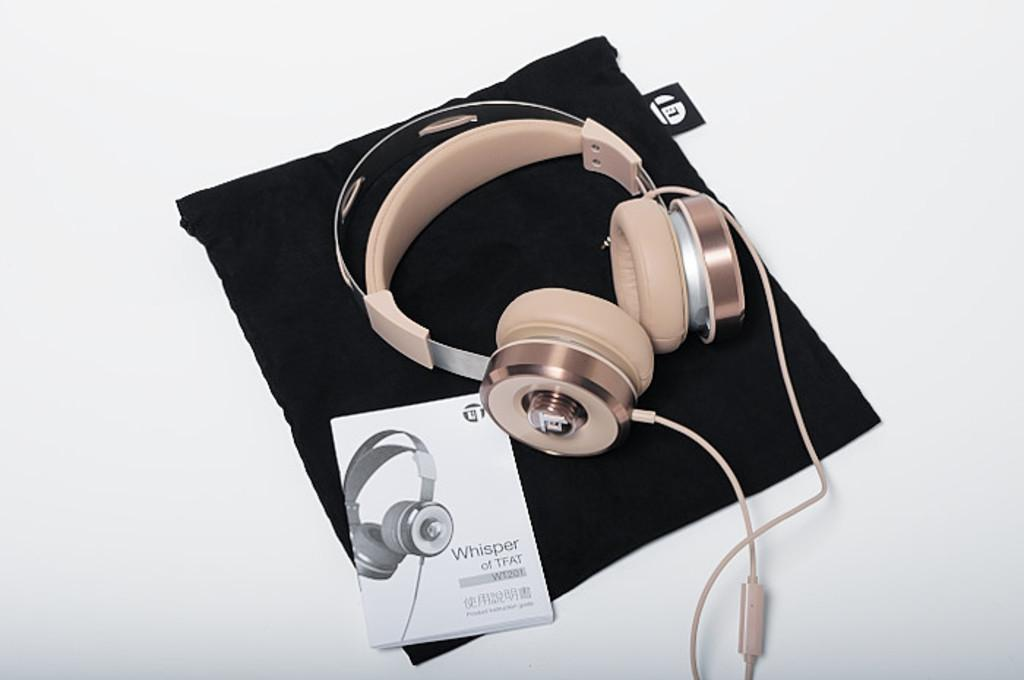What type of electronic device is present in the image? There is a headphone in the image. What can be used as a reference or guide in the image? There is a manual in the image. What color is the cloth visible in the image? The cloth in the image is black. What type of government is depicted in the image? There is no depiction of a government in the image; it features a headphone, manual, and black cloth. What impulse can be seen affecting the headphone in the image? There is no impulse affecting the headphone in the image; it is stationary. 